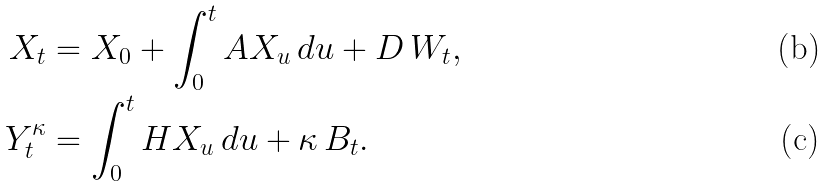<formula> <loc_0><loc_0><loc_500><loc_500>X _ { t } & = X _ { 0 } + \int _ { 0 } ^ { t } A X _ { u } \, d u + D \, W _ { t } , \\ Y _ { t } ^ { \kappa } & = \int _ { 0 } ^ { t } H X _ { u } \, d u + \kappa \, B _ { t } .</formula> 